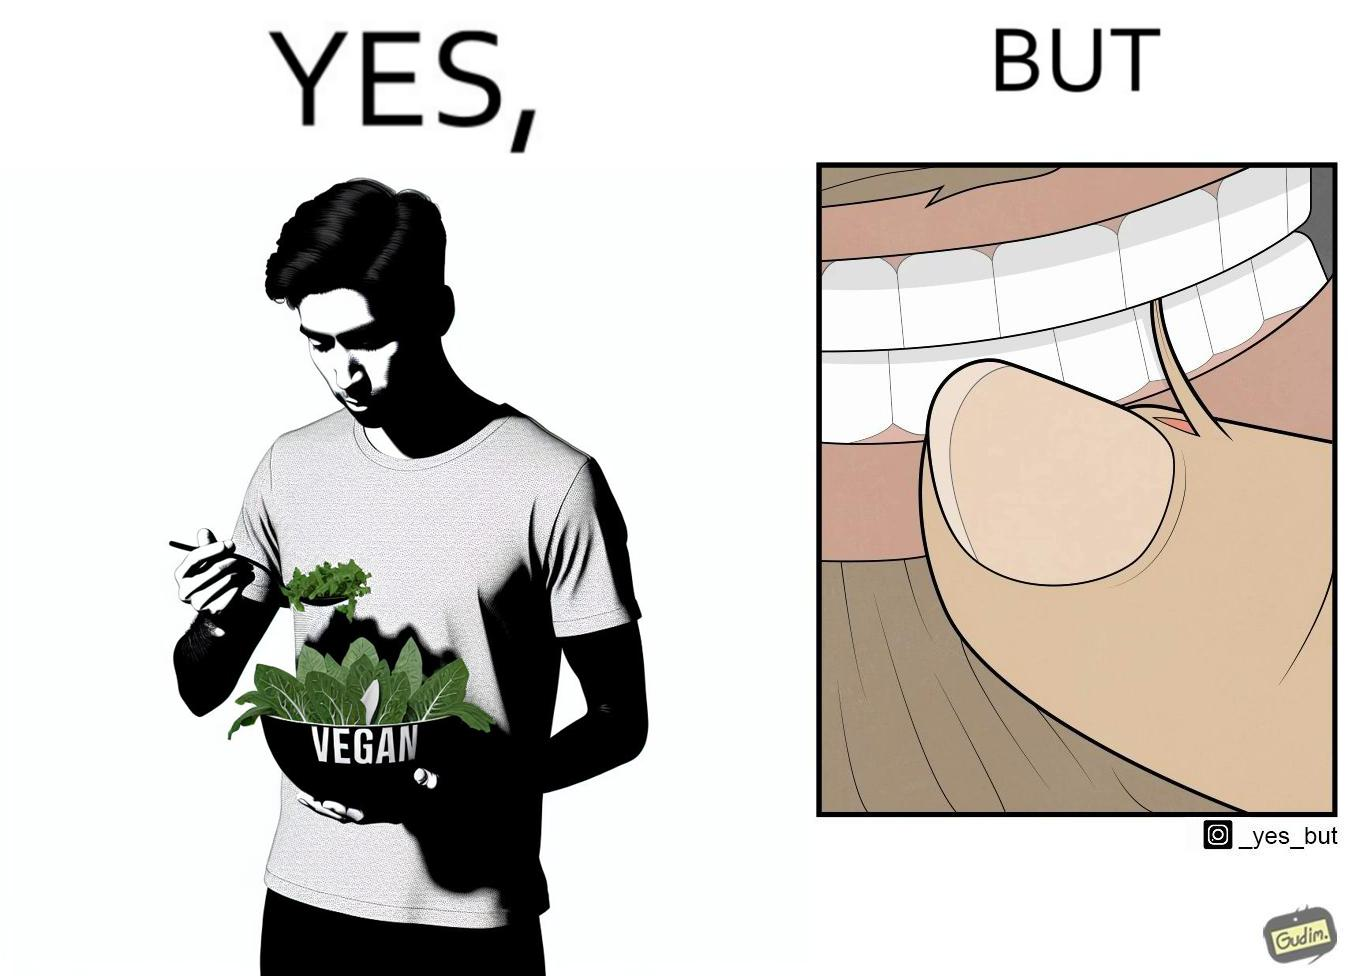What is shown in this image? The image is funny because while the man claims to be vegan, he is biting skin off his own hand. 